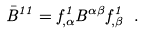<formula> <loc_0><loc_0><loc_500><loc_500>\bar { B } ^ { 1 1 } = f ^ { 1 } _ { , \alpha } B ^ { \alpha \beta } f ^ { 1 } _ { , \beta } \ .</formula> 